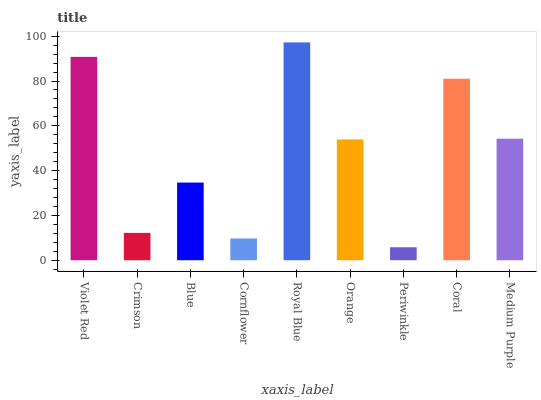Is Periwinkle the minimum?
Answer yes or no. Yes. Is Royal Blue the maximum?
Answer yes or no. Yes. Is Crimson the minimum?
Answer yes or no. No. Is Crimson the maximum?
Answer yes or no. No. Is Violet Red greater than Crimson?
Answer yes or no. Yes. Is Crimson less than Violet Red?
Answer yes or no. Yes. Is Crimson greater than Violet Red?
Answer yes or no. No. Is Violet Red less than Crimson?
Answer yes or no. No. Is Orange the high median?
Answer yes or no. Yes. Is Orange the low median?
Answer yes or no. Yes. Is Blue the high median?
Answer yes or no. No. Is Medium Purple the low median?
Answer yes or no. No. 